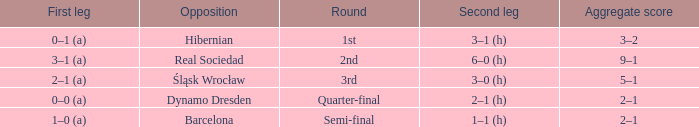What was the first leg against Hibernian? 0–1 (a). 